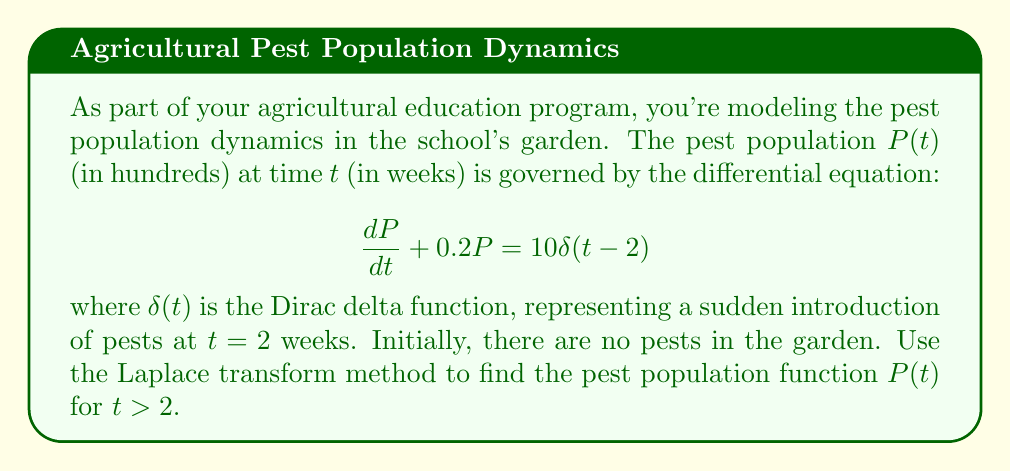Help me with this question. Let's solve this step-by-step using the Laplace transform method:

1) Take the Laplace transform of both sides of the equation:
   $$\mathcal{L}\left\{\frac{dP}{dt} + 0.2P\right\} = \mathcal{L}\{10\delta(t-2)\}$$

2) Using Laplace transform properties:
   $$sP(s) - P(0) + 0.2P(s) = 10e^{-2s}$$
   where $P(s)$ is the Laplace transform of $P(t)$, and $P(0) = 0$ (initial condition).

3) Simplify:
   $$(s + 0.2)P(s) = 10e^{-2s}$$

4) Solve for $P(s)$:
   $$P(s) = \frac{10e^{-2s}}{s + 0.2}$$

5) To find $P(t)$, we need to take the inverse Laplace transform:
   $$P(t) = \mathcal{L}^{-1}\left\{\frac{10e^{-2s}}{s + 0.2}\right\}$$

6) Using the time shift property of Laplace transforms:
   $$P(t) = 10u(t-2)e^{-0.2(t-2)}$$
   where $u(t)$ is the unit step function.

7) For $t > 2$, $u(t-2) = 1$, so our final solution is:
   $$P(t) = 10e^{-0.2(t-2)} \quad \text{for } t > 2$$
Answer: $P(t) = 10e^{-0.2(t-2)}$ for $t > 2$ 